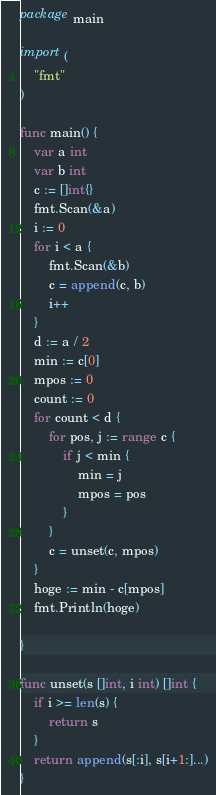Convert code to text. <code><loc_0><loc_0><loc_500><loc_500><_Go_>package main

import (
	"fmt"
)

func main() {
	var a int
	var b int
	c := []int{}
	fmt.Scan(&a)
	i := 0
	for i < a {
		fmt.Scan(&b)
		c = append(c, b)
		i++
	}
	d := a / 2
	min := c[0]
	mpos := 0
	count := 0
	for count < d {
		for pos, j := range c {
			if j < min {
				min = j
				mpos = pos
			}
		}
		c = unset(c, mpos)
	}
	hoge := min - c[mpos]
	fmt.Println(hoge)

}

func unset(s []int, i int) []int {
	if i >= len(s) {
		return s
	}
	return append(s[:i], s[i+1:]...)
}
</code> 